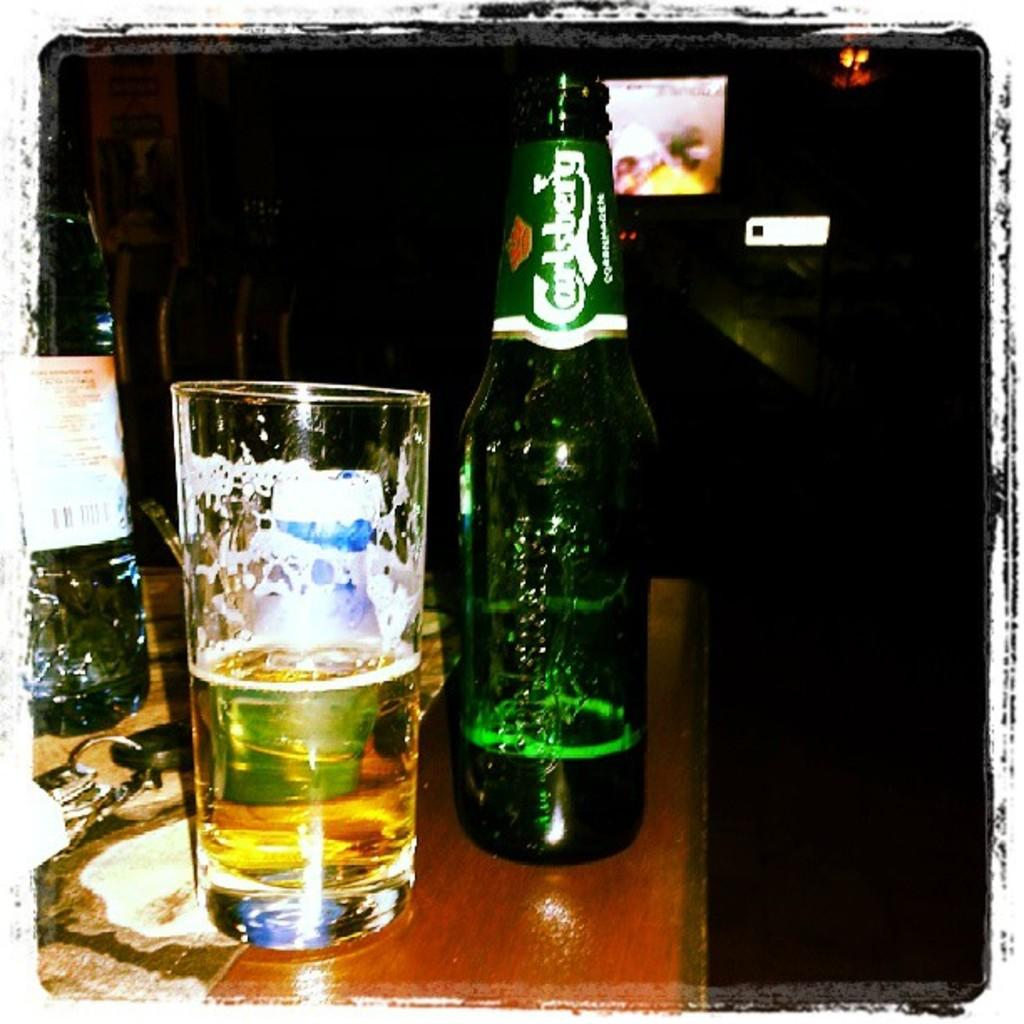<image>
Give a short and clear explanation of the subsequent image. An almost empty bottle of Carlsberg sits beside a half full glass on a bar. 